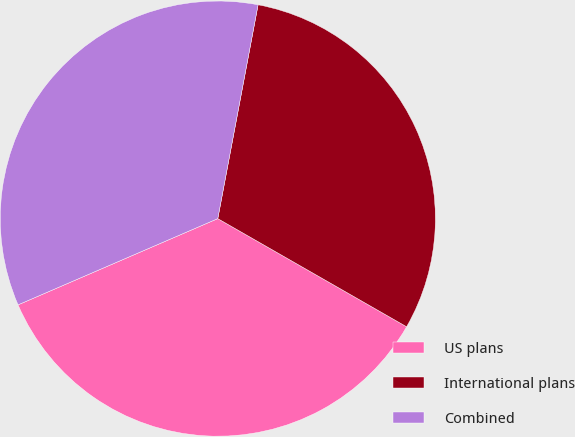Convert chart. <chart><loc_0><loc_0><loc_500><loc_500><pie_chart><fcel>US plans<fcel>International plans<fcel>Combined<nl><fcel>35.23%<fcel>30.31%<fcel>34.45%<nl></chart> 